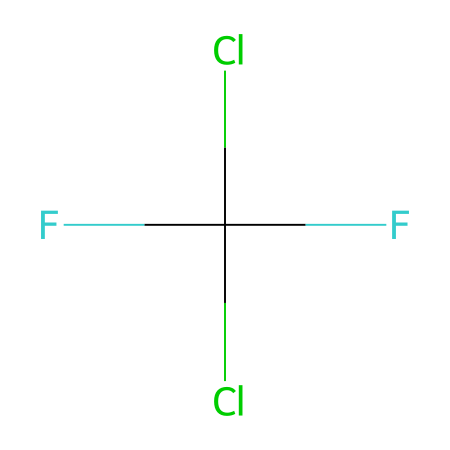What is the total number of chlorine atoms in Freon-12? The SMILES representation shows "Cl" which indicates chlorine atoms; there are two occurrences of "Cl" in the chemical structure.
Answer: two How many fluorine atoms are present in Freon-12? According to the SMILES structure, "F" represents fluorine atoms; there are two occurrences of "F" in the chemical representation.
Answer: two What type of molecule is Freon-12? The presence of chlorine and fluorine along with carbon in the structure categorizes Freon-12 as a chlorofluorocarbon.
Answer: chlorofluorocarbon Why does Freon-12 have potential environmental concerns? Freon-12, being a chlorofluorocarbon, contributes to ozone depletion when released into the atmosphere, due to the presence of chlorine atoms that break down ozone molecules.
Answer: ozone depletion What is the molecular formula for Freon-12? By analyzing the SMILES representation, we see that Freon-12 consists of 1 carbon atom, 2 chlorine atoms, and 2 fluorine atoms, leading to the molecular formula CCl2F2.
Answer: CCl2F2 How does the number of chlorine atoms in Freon-12 affect its properties? The two chlorine atoms in Freon-12 increase its stability and lower its boiling point, making it effective as a refrigerant, but also contribute to its ozone-depleting potential when it breaks down.
Answer: stability and low boiling point 